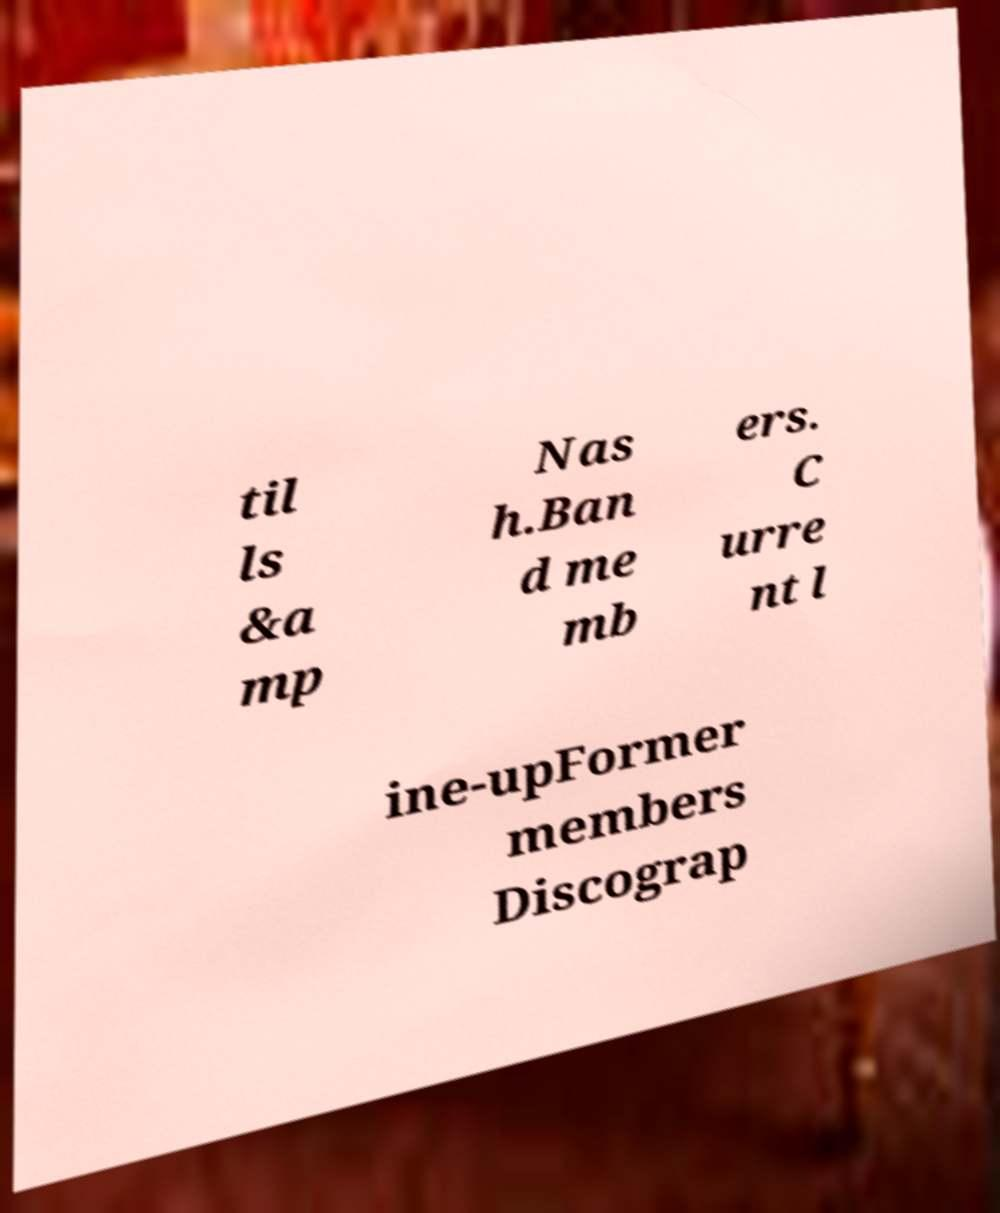Can you accurately transcribe the text from the provided image for me? til ls &a mp Nas h.Ban d me mb ers. C urre nt l ine-upFormer members Discograp 